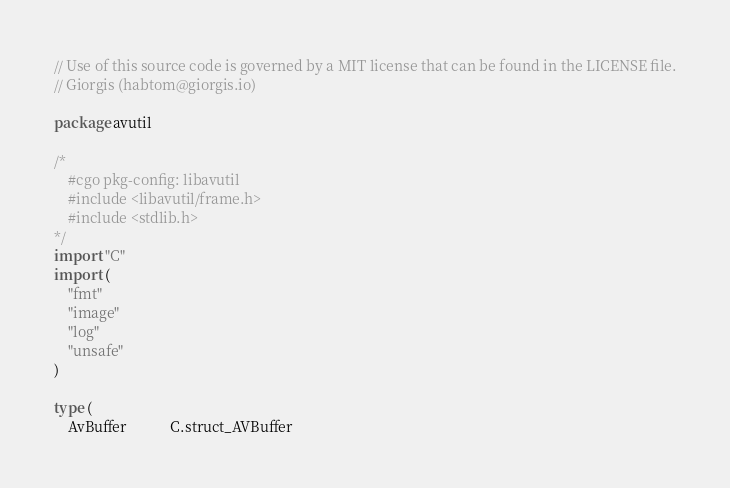Convert code to text. <code><loc_0><loc_0><loc_500><loc_500><_Go_>// Use of this source code is governed by a MIT license that can be found in the LICENSE file.
// Giorgis (habtom@giorgis.io)

package avutil

/*
	#cgo pkg-config: libavutil
	#include <libavutil/frame.h>
	#include <stdlib.h>
*/
import "C"
import (
	"fmt"
	"image"
	"log"
	"unsafe"
)

type (
	AvBuffer            C.struct_AVBuffer</code> 